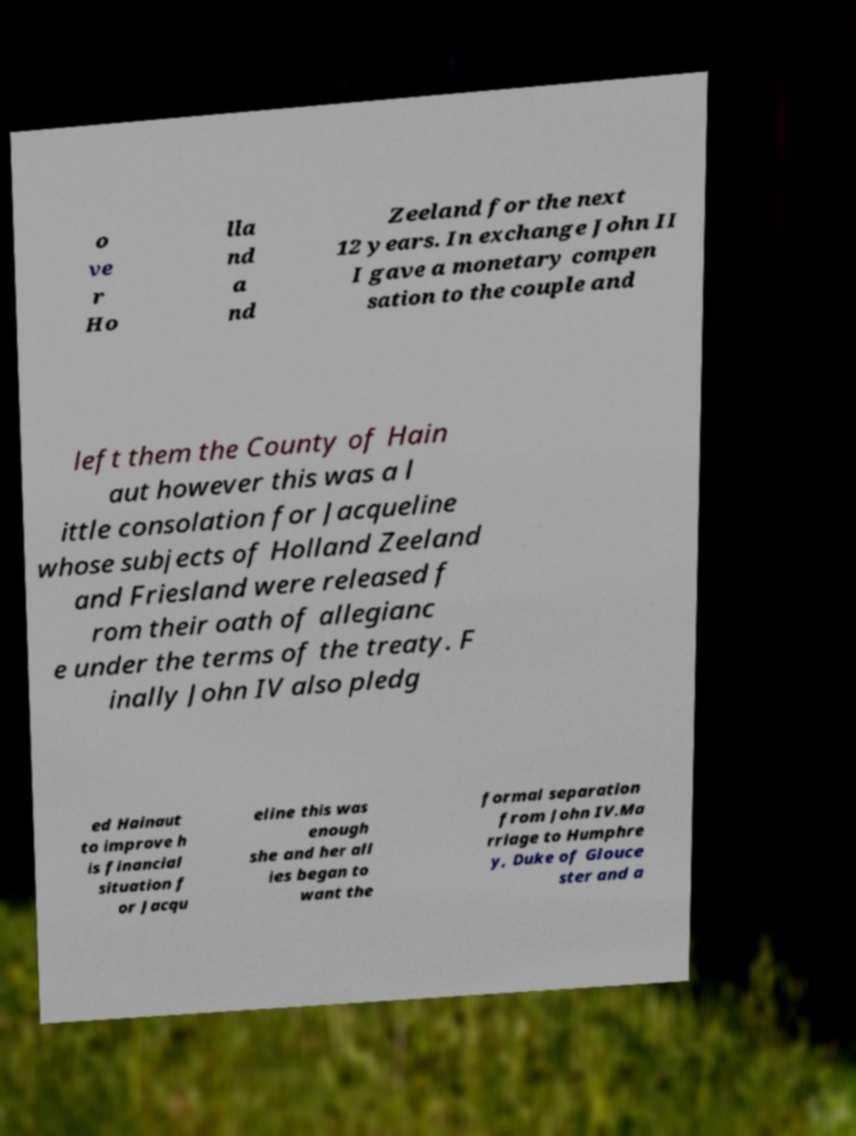Could you extract and type out the text from this image? o ve r Ho lla nd a nd Zeeland for the next 12 years. In exchange John II I gave a monetary compen sation to the couple and left them the County of Hain aut however this was a l ittle consolation for Jacqueline whose subjects of Holland Zeeland and Friesland were released f rom their oath of allegianc e under the terms of the treaty. F inally John IV also pledg ed Hainaut to improve h is financial situation f or Jacqu eline this was enough she and her all ies began to want the formal separation from John IV.Ma rriage to Humphre y, Duke of Glouce ster and a 